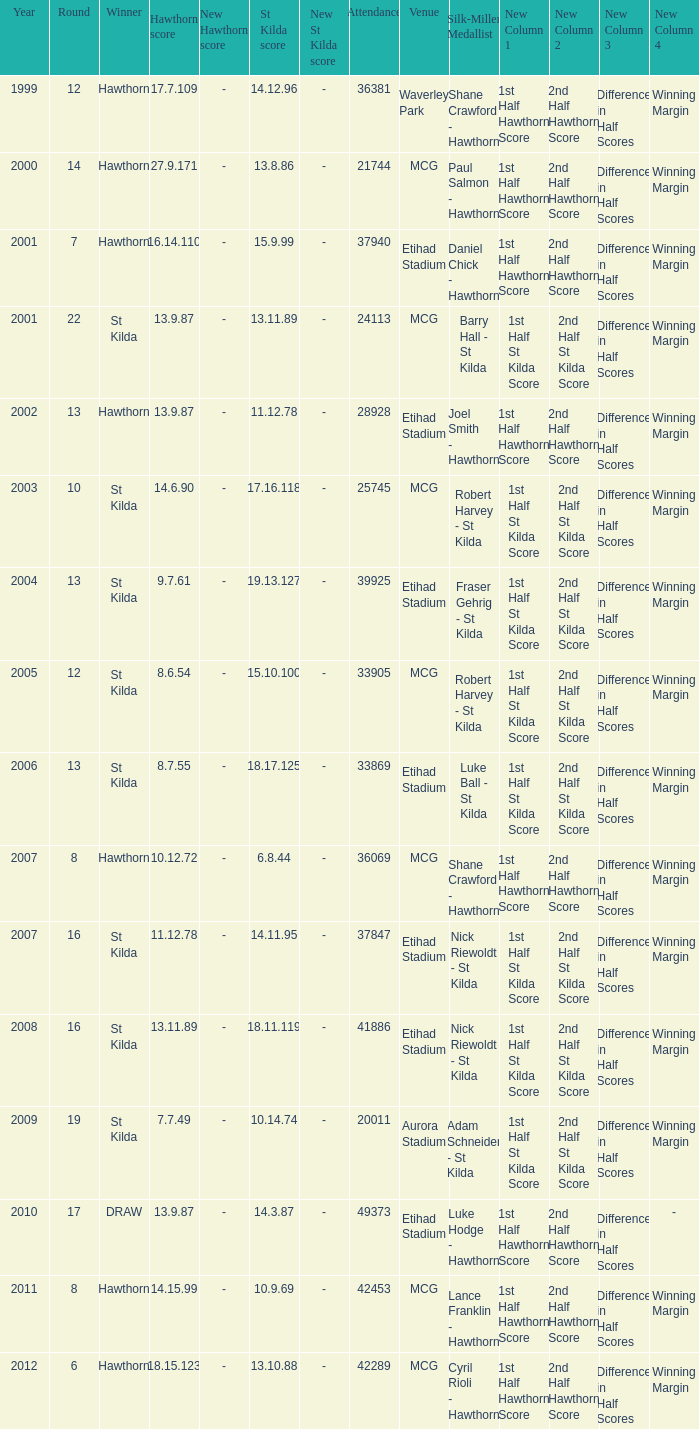Can you parse all the data within this table? {'header': ['Year', 'Round', 'Winner', 'Hawthorn score', 'New Hawthorn score', 'St Kilda score', 'New St Kilda score', 'Attendance', 'Venue', 'Silk-Miller Medallist', 'New Column 1', 'New Column 2', 'New Column 3', 'New Column 4'], 'rows': [['1999', '12', 'Hawthorn', '17.7.109', '-', '14.12.96', '-', '36381', 'Waverley Park', 'Shane Crawford - Hawthorn', '1st Half Hawthorn Score', '2nd Half Hawthorn Score', 'Difference in Half Scores', 'Winning Margin'], ['2000', '14', 'Hawthorn', '27.9.171', '-', '13.8.86', '-', '21744', 'MCG', 'Paul Salmon - Hawthorn', '1st Half Hawthorn Score', '2nd Half Hawthorn Score', 'Difference in Half Scores', 'Winning Margin'], ['2001', '7', 'Hawthorn', '16.14.110', '-', '15.9.99', '-', '37940', 'Etihad Stadium', 'Daniel Chick - Hawthorn', '1st Half Hawthorn Score', '2nd Half Hawthorn Score', 'Difference in Half Scores', 'Winning Margin'], ['2001', '22', 'St Kilda', '13.9.87', '-', '13.11.89', '-', '24113', 'MCG', 'Barry Hall - St Kilda', '1st Half St Kilda Score', '2nd Half St Kilda Score', 'Difference in Half Scores', 'Winning Margin'], ['2002', '13', 'Hawthorn', '13.9.87', '-', '11.12.78', '-', '28928', 'Etihad Stadium', 'Joel Smith - Hawthorn', '1st Half Hawthorn Score', '2nd Half Hawthorn Score', 'Difference in Half Scores', 'Winning Margin'], ['2003', '10', 'St Kilda', '14.6.90', '-', '17.16.118', '-', '25745', 'MCG', 'Robert Harvey - St Kilda', '1st Half St Kilda Score', '2nd Half St Kilda Score', 'Difference in Half Scores', 'Winning Margin'], ['2004', '13', 'St Kilda', '9.7.61', '-', '19.13.127', '-', '39925', 'Etihad Stadium', 'Fraser Gehrig - St Kilda', '1st Half St Kilda Score', '2nd Half St Kilda Score', 'Difference in Half Scores', 'Winning Margin'], ['2005', '12', 'St Kilda', '8.6.54', '-', '15.10.100', '-', '33905', 'MCG', 'Robert Harvey - St Kilda', '1st Half St Kilda Score', '2nd Half St Kilda Score', 'Difference in Half Scores', 'Winning Margin'], ['2006', '13', 'St Kilda', '8.7.55', '-', '18.17.125', '-', '33869', 'Etihad Stadium', 'Luke Ball - St Kilda', '1st Half St Kilda Score', '2nd Half St Kilda Score', 'Difference in Half Scores', 'Winning Margin'], ['2007', '8', 'Hawthorn', '10.12.72', '-', '6.8.44', '-', '36069', 'MCG', 'Shane Crawford - Hawthorn', '1st Half Hawthorn Score', '2nd Half Hawthorn Score', 'Difference in Half Scores', 'Winning Margin'], ['2007', '16', 'St Kilda', '11.12.78', '-', '14.11.95', '-', '37847', 'Etihad Stadium', 'Nick Riewoldt - St Kilda', '1st Half St Kilda Score', '2nd Half St Kilda Score', 'Difference in Half Scores', 'Winning Margin'], ['2008', '16', 'St Kilda', '13.11.89', '-', '18.11.119', '-', '41886', 'Etihad Stadium', 'Nick Riewoldt - St Kilda', '1st Half St Kilda Score', '2nd Half St Kilda Score', 'Difference in Half Scores', 'Winning Margin'], ['2009', '19', 'St Kilda', '7.7.49', '-', '10.14.74', '-', '20011', 'Aurora Stadium', 'Adam Schneider - St Kilda', '1st Half St Kilda Score', '2nd Half St Kilda Score', 'Difference in Half Scores', 'Winning Margin'], ['2010', '17', 'DRAW', '13.9.87', '-', '14.3.87', '-', '49373', 'Etihad Stadium', 'Luke Hodge - Hawthorn', '1st Half Hawthorn Score', '2nd Half Hawthorn Score', 'Difference in Half Scores', '-'], ['2011', '8', 'Hawthorn', '14.15.99', '-', '10.9.69', '-', '42453', 'MCG', 'Lance Franklin - Hawthorn', '1st Half Hawthorn Score', '2nd Half Hawthorn Score', 'Difference in Half Scores', 'Winning Margin'], ['2012', '6', 'Hawthorn', '18.15.123', '-', '13.10.88', '-', '42289', 'MCG', 'Cyril Rioli - Hawthorn', '1st Half Hawthorn Score', '2nd Half Hawthorn Score', 'Difference in Half Scores', 'Winning Margin']]} What the listed in round when the hawthorn score is 17.7.109? 12.0. 